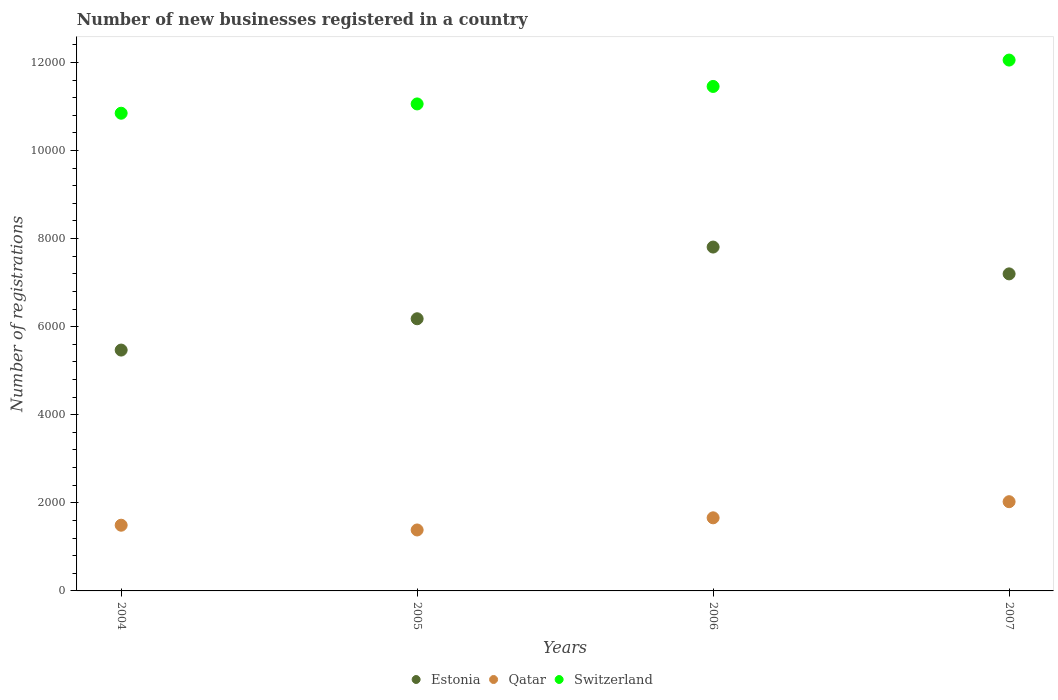How many different coloured dotlines are there?
Provide a short and direct response. 3. What is the number of new businesses registered in Qatar in 2007?
Keep it short and to the point. 2026. Across all years, what is the maximum number of new businesses registered in Qatar?
Ensure brevity in your answer.  2026. Across all years, what is the minimum number of new businesses registered in Qatar?
Your answer should be compact. 1384. In which year was the number of new businesses registered in Estonia minimum?
Your answer should be very brief. 2004. What is the total number of new businesses registered in Estonia in the graph?
Offer a very short reply. 2.67e+04. What is the difference between the number of new businesses registered in Estonia in 2004 and that in 2007?
Offer a very short reply. -1730. What is the difference between the number of new businesses registered in Switzerland in 2004 and the number of new businesses registered in Estonia in 2007?
Provide a short and direct response. 3648. What is the average number of new businesses registered in Switzerland per year?
Offer a very short reply. 1.14e+04. In the year 2005, what is the difference between the number of new businesses registered in Qatar and number of new businesses registered in Estonia?
Provide a short and direct response. -4796. In how many years, is the number of new businesses registered in Estonia greater than 5600?
Give a very brief answer. 3. What is the ratio of the number of new businesses registered in Estonia in 2006 to that in 2007?
Provide a short and direct response. 1.08. Is the difference between the number of new businesses registered in Qatar in 2005 and 2006 greater than the difference between the number of new businesses registered in Estonia in 2005 and 2006?
Your answer should be compact. Yes. What is the difference between the highest and the second highest number of new businesses registered in Switzerland?
Offer a terse response. 599. What is the difference between the highest and the lowest number of new businesses registered in Qatar?
Offer a terse response. 642. Is the sum of the number of new businesses registered in Switzerland in 2005 and 2007 greater than the maximum number of new businesses registered in Qatar across all years?
Offer a terse response. Yes. Is the number of new businesses registered in Switzerland strictly less than the number of new businesses registered in Estonia over the years?
Your answer should be very brief. No. How many years are there in the graph?
Your response must be concise. 4. Does the graph contain grids?
Keep it short and to the point. No. Where does the legend appear in the graph?
Offer a very short reply. Bottom center. What is the title of the graph?
Provide a succinct answer. Number of new businesses registered in a country. Does "Albania" appear as one of the legend labels in the graph?
Ensure brevity in your answer.  No. What is the label or title of the X-axis?
Your response must be concise. Years. What is the label or title of the Y-axis?
Make the answer very short. Number of registrations. What is the Number of registrations of Estonia in 2004?
Your response must be concise. 5469. What is the Number of registrations in Qatar in 2004?
Ensure brevity in your answer.  1492. What is the Number of registrations of Switzerland in 2004?
Offer a terse response. 1.08e+04. What is the Number of registrations of Estonia in 2005?
Provide a short and direct response. 6180. What is the Number of registrations in Qatar in 2005?
Give a very brief answer. 1384. What is the Number of registrations in Switzerland in 2005?
Offer a terse response. 1.11e+04. What is the Number of registrations of Estonia in 2006?
Offer a very short reply. 7808. What is the Number of registrations of Qatar in 2006?
Offer a very short reply. 1660. What is the Number of registrations of Switzerland in 2006?
Your response must be concise. 1.15e+04. What is the Number of registrations of Estonia in 2007?
Offer a terse response. 7199. What is the Number of registrations of Qatar in 2007?
Give a very brief answer. 2026. What is the Number of registrations of Switzerland in 2007?
Make the answer very short. 1.21e+04. Across all years, what is the maximum Number of registrations in Estonia?
Make the answer very short. 7808. Across all years, what is the maximum Number of registrations of Qatar?
Make the answer very short. 2026. Across all years, what is the maximum Number of registrations of Switzerland?
Your answer should be compact. 1.21e+04. Across all years, what is the minimum Number of registrations in Estonia?
Your response must be concise. 5469. Across all years, what is the minimum Number of registrations of Qatar?
Provide a short and direct response. 1384. Across all years, what is the minimum Number of registrations of Switzerland?
Offer a very short reply. 1.08e+04. What is the total Number of registrations of Estonia in the graph?
Offer a terse response. 2.67e+04. What is the total Number of registrations of Qatar in the graph?
Make the answer very short. 6562. What is the total Number of registrations of Switzerland in the graph?
Provide a short and direct response. 4.54e+04. What is the difference between the Number of registrations of Estonia in 2004 and that in 2005?
Ensure brevity in your answer.  -711. What is the difference between the Number of registrations in Qatar in 2004 and that in 2005?
Make the answer very short. 108. What is the difference between the Number of registrations in Switzerland in 2004 and that in 2005?
Your response must be concise. -211. What is the difference between the Number of registrations of Estonia in 2004 and that in 2006?
Offer a terse response. -2339. What is the difference between the Number of registrations of Qatar in 2004 and that in 2006?
Ensure brevity in your answer.  -168. What is the difference between the Number of registrations in Switzerland in 2004 and that in 2006?
Provide a short and direct response. -608. What is the difference between the Number of registrations in Estonia in 2004 and that in 2007?
Your answer should be compact. -1730. What is the difference between the Number of registrations in Qatar in 2004 and that in 2007?
Keep it short and to the point. -534. What is the difference between the Number of registrations in Switzerland in 2004 and that in 2007?
Your answer should be very brief. -1207. What is the difference between the Number of registrations in Estonia in 2005 and that in 2006?
Your answer should be very brief. -1628. What is the difference between the Number of registrations in Qatar in 2005 and that in 2006?
Offer a terse response. -276. What is the difference between the Number of registrations of Switzerland in 2005 and that in 2006?
Make the answer very short. -397. What is the difference between the Number of registrations of Estonia in 2005 and that in 2007?
Provide a short and direct response. -1019. What is the difference between the Number of registrations in Qatar in 2005 and that in 2007?
Offer a terse response. -642. What is the difference between the Number of registrations of Switzerland in 2005 and that in 2007?
Offer a very short reply. -996. What is the difference between the Number of registrations of Estonia in 2006 and that in 2007?
Offer a terse response. 609. What is the difference between the Number of registrations of Qatar in 2006 and that in 2007?
Provide a succinct answer. -366. What is the difference between the Number of registrations in Switzerland in 2006 and that in 2007?
Provide a short and direct response. -599. What is the difference between the Number of registrations of Estonia in 2004 and the Number of registrations of Qatar in 2005?
Provide a succinct answer. 4085. What is the difference between the Number of registrations in Estonia in 2004 and the Number of registrations in Switzerland in 2005?
Ensure brevity in your answer.  -5589. What is the difference between the Number of registrations in Qatar in 2004 and the Number of registrations in Switzerland in 2005?
Your answer should be compact. -9566. What is the difference between the Number of registrations of Estonia in 2004 and the Number of registrations of Qatar in 2006?
Give a very brief answer. 3809. What is the difference between the Number of registrations in Estonia in 2004 and the Number of registrations in Switzerland in 2006?
Provide a short and direct response. -5986. What is the difference between the Number of registrations of Qatar in 2004 and the Number of registrations of Switzerland in 2006?
Provide a short and direct response. -9963. What is the difference between the Number of registrations in Estonia in 2004 and the Number of registrations in Qatar in 2007?
Give a very brief answer. 3443. What is the difference between the Number of registrations in Estonia in 2004 and the Number of registrations in Switzerland in 2007?
Your response must be concise. -6585. What is the difference between the Number of registrations in Qatar in 2004 and the Number of registrations in Switzerland in 2007?
Ensure brevity in your answer.  -1.06e+04. What is the difference between the Number of registrations in Estonia in 2005 and the Number of registrations in Qatar in 2006?
Offer a terse response. 4520. What is the difference between the Number of registrations in Estonia in 2005 and the Number of registrations in Switzerland in 2006?
Offer a very short reply. -5275. What is the difference between the Number of registrations in Qatar in 2005 and the Number of registrations in Switzerland in 2006?
Provide a succinct answer. -1.01e+04. What is the difference between the Number of registrations in Estonia in 2005 and the Number of registrations in Qatar in 2007?
Make the answer very short. 4154. What is the difference between the Number of registrations in Estonia in 2005 and the Number of registrations in Switzerland in 2007?
Keep it short and to the point. -5874. What is the difference between the Number of registrations of Qatar in 2005 and the Number of registrations of Switzerland in 2007?
Provide a succinct answer. -1.07e+04. What is the difference between the Number of registrations of Estonia in 2006 and the Number of registrations of Qatar in 2007?
Your response must be concise. 5782. What is the difference between the Number of registrations of Estonia in 2006 and the Number of registrations of Switzerland in 2007?
Offer a terse response. -4246. What is the difference between the Number of registrations of Qatar in 2006 and the Number of registrations of Switzerland in 2007?
Offer a very short reply. -1.04e+04. What is the average Number of registrations of Estonia per year?
Provide a succinct answer. 6664. What is the average Number of registrations of Qatar per year?
Make the answer very short. 1640.5. What is the average Number of registrations in Switzerland per year?
Your response must be concise. 1.14e+04. In the year 2004, what is the difference between the Number of registrations of Estonia and Number of registrations of Qatar?
Provide a succinct answer. 3977. In the year 2004, what is the difference between the Number of registrations in Estonia and Number of registrations in Switzerland?
Give a very brief answer. -5378. In the year 2004, what is the difference between the Number of registrations in Qatar and Number of registrations in Switzerland?
Your answer should be compact. -9355. In the year 2005, what is the difference between the Number of registrations in Estonia and Number of registrations in Qatar?
Keep it short and to the point. 4796. In the year 2005, what is the difference between the Number of registrations of Estonia and Number of registrations of Switzerland?
Offer a very short reply. -4878. In the year 2005, what is the difference between the Number of registrations in Qatar and Number of registrations in Switzerland?
Your answer should be compact. -9674. In the year 2006, what is the difference between the Number of registrations in Estonia and Number of registrations in Qatar?
Your response must be concise. 6148. In the year 2006, what is the difference between the Number of registrations of Estonia and Number of registrations of Switzerland?
Make the answer very short. -3647. In the year 2006, what is the difference between the Number of registrations in Qatar and Number of registrations in Switzerland?
Make the answer very short. -9795. In the year 2007, what is the difference between the Number of registrations in Estonia and Number of registrations in Qatar?
Provide a short and direct response. 5173. In the year 2007, what is the difference between the Number of registrations in Estonia and Number of registrations in Switzerland?
Your response must be concise. -4855. In the year 2007, what is the difference between the Number of registrations in Qatar and Number of registrations in Switzerland?
Keep it short and to the point. -1.00e+04. What is the ratio of the Number of registrations in Estonia in 2004 to that in 2005?
Provide a short and direct response. 0.89. What is the ratio of the Number of registrations in Qatar in 2004 to that in 2005?
Make the answer very short. 1.08. What is the ratio of the Number of registrations of Switzerland in 2004 to that in 2005?
Offer a very short reply. 0.98. What is the ratio of the Number of registrations in Estonia in 2004 to that in 2006?
Your answer should be very brief. 0.7. What is the ratio of the Number of registrations of Qatar in 2004 to that in 2006?
Your answer should be compact. 0.9. What is the ratio of the Number of registrations of Switzerland in 2004 to that in 2006?
Offer a very short reply. 0.95. What is the ratio of the Number of registrations of Estonia in 2004 to that in 2007?
Your answer should be very brief. 0.76. What is the ratio of the Number of registrations of Qatar in 2004 to that in 2007?
Ensure brevity in your answer.  0.74. What is the ratio of the Number of registrations of Switzerland in 2004 to that in 2007?
Your response must be concise. 0.9. What is the ratio of the Number of registrations of Estonia in 2005 to that in 2006?
Provide a short and direct response. 0.79. What is the ratio of the Number of registrations of Qatar in 2005 to that in 2006?
Your answer should be compact. 0.83. What is the ratio of the Number of registrations in Switzerland in 2005 to that in 2006?
Ensure brevity in your answer.  0.97. What is the ratio of the Number of registrations of Estonia in 2005 to that in 2007?
Your answer should be very brief. 0.86. What is the ratio of the Number of registrations in Qatar in 2005 to that in 2007?
Give a very brief answer. 0.68. What is the ratio of the Number of registrations of Switzerland in 2005 to that in 2007?
Make the answer very short. 0.92. What is the ratio of the Number of registrations of Estonia in 2006 to that in 2007?
Your answer should be very brief. 1.08. What is the ratio of the Number of registrations in Qatar in 2006 to that in 2007?
Your answer should be compact. 0.82. What is the ratio of the Number of registrations of Switzerland in 2006 to that in 2007?
Keep it short and to the point. 0.95. What is the difference between the highest and the second highest Number of registrations of Estonia?
Your response must be concise. 609. What is the difference between the highest and the second highest Number of registrations of Qatar?
Offer a very short reply. 366. What is the difference between the highest and the second highest Number of registrations of Switzerland?
Offer a very short reply. 599. What is the difference between the highest and the lowest Number of registrations of Estonia?
Make the answer very short. 2339. What is the difference between the highest and the lowest Number of registrations of Qatar?
Make the answer very short. 642. What is the difference between the highest and the lowest Number of registrations in Switzerland?
Give a very brief answer. 1207. 